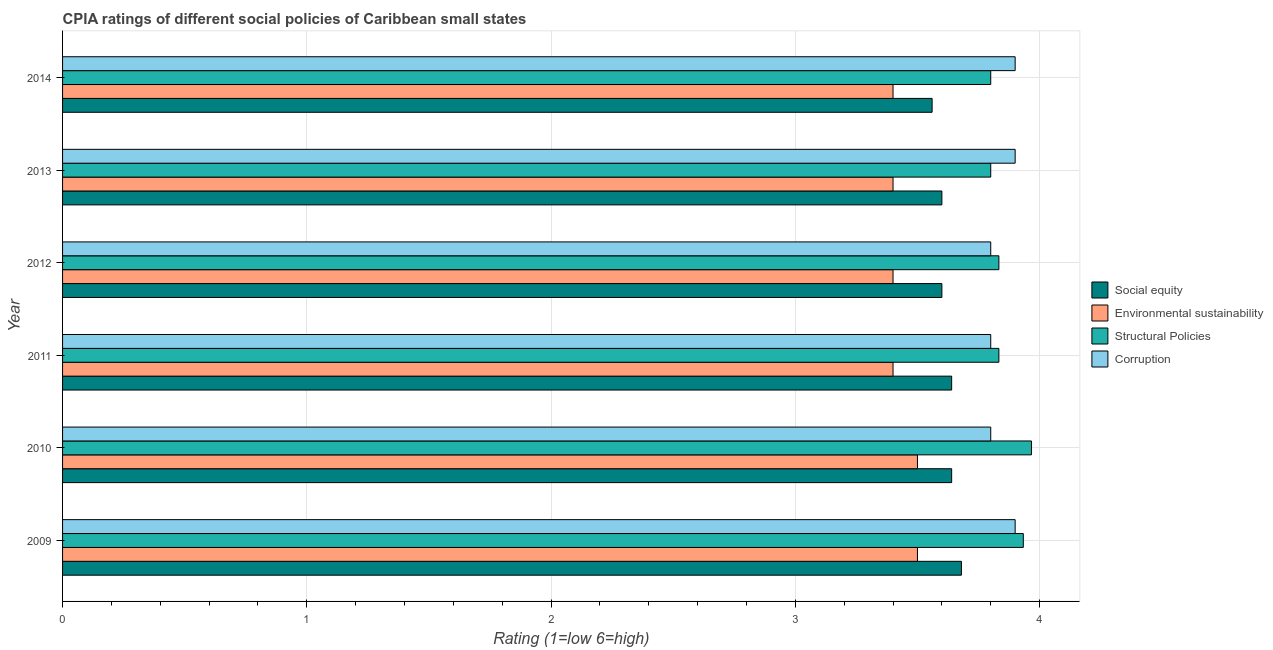How many groups of bars are there?
Ensure brevity in your answer.  6. Are the number of bars per tick equal to the number of legend labels?
Offer a terse response. Yes. Are the number of bars on each tick of the Y-axis equal?
Provide a short and direct response. Yes. How many bars are there on the 2nd tick from the bottom?
Provide a succinct answer. 4. What is the cpia rating of environmental sustainability in 2014?
Ensure brevity in your answer.  3.4. Across all years, what is the maximum cpia rating of corruption?
Provide a succinct answer. 3.9. Across all years, what is the minimum cpia rating of corruption?
Provide a short and direct response. 3.8. In which year was the cpia rating of social equity maximum?
Give a very brief answer. 2009. What is the total cpia rating of environmental sustainability in the graph?
Offer a very short reply. 20.6. What is the difference between the cpia rating of social equity in 2012 and that in 2013?
Your response must be concise. 0. What is the difference between the cpia rating of structural policies in 2013 and the cpia rating of environmental sustainability in 2011?
Ensure brevity in your answer.  0.4. What is the average cpia rating of environmental sustainability per year?
Your response must be concise. 3.43. In the year 2011, what is the difference between the cpia rating of corruption and cpia rating of structural policies?
Provide a succinct answer. -0.03. In how many years, is the cpia rating of social equity greater than 2.2 ?
Provide a short and direct response. 6. Is the cpia rating of environmental sustainability in 2009 less than that in 2012?
Offer a terse response. No. Is the difference between the cpia rating of corruption in 2013 and 2014 greater than the difference between the cpia rating of structural policies in 2013 and 2014?
Keep it short and to the point. No. What is the difference between the highest and the second highest cpia rating of social equity?
Your response must be concise. 0.04. What is the difference between the highest and the lowest cpia rating of structural policies?
Provide a succinct answer. 0.17. Is the sum of the cpia rating of social equity in 2009 and 2011 greater than the maximum cpia rating of corruption across all years?
Your answer should be compact. Yes. What does the 4th bar from the top in 2009 represents?
Give a very brief answer. Social equity. What does the 2nd bar from the bottom in 2012 represents?
Your answer should be very brief. Environmental sustainability. How many bars are there?
Provide a succinct answer. 24. How many years are there in the graph?
Offer a very short reply. 6. What is the difference between two consecutive major ticks on the X-axis?
Provide a succinct answer. 1. Are the values on the major ticks of X-axis written in scientific E-notation?
Ensure brevity in your answer.  No. Does the graph contain any zero values?
Offer a very short reply. No. How are the legend labels stacked?
Your response must be concise. Vertical. What is the title of the graph?
Offer a terse response. CPIA ratings of different social policies of Caribbean small states. Does "Taxes on goods and services" appear as one of the legend labels in the graph?
Offer a very short reply. No. What is the label or title of the X-axis?
Give a very brief answer. Rating (1=low 6=high). What is the Rating (1=low 6=high) of Social equity in 2009?
Give a very brief answer. 3.68. What is the Rating (1=low 6=high) of Structural Policies in 2009?
Provide a short and direct response. 3.93. What is the Rating (1=low 6=high) in Social equity in 2010?
Keep it short and to the point. 3.64. What is the Rating (1=low 6=high) in Structural Policies in 2010?
Give a very brief answer. 3.97. What is the Rating (1=low 6=high) of Social equity in 2011?
Make the answer very short. 3.64. What is the Rating (1=low 6=high) of Structural Policies in 2011?
Provide a short and direct response. 3.83. What is the Rating (1=low 6=high) in Structural Policies in 2012?
Provide a short and direct response. 3.83. What is the Rating (1=low 6=high) of Corruption in 2012?
Offer a terse response. 3.8. What is the Rating (1=low 6=high) in Social equity in 2013?
Offer a terse response. 3.6. What is the Rating (1=low 6=high) in Corruption in 2013?
Ensure brevity in your answer.  3.9. What is the Rating (1=low 6=high) of Social equity in 2014?
Offer a very short reply. 3.56. What is the Rating (1=low 6=high) in Structural Policies in 2014?
Provide a short and direct response. 3.8. What is the Rating (1=low 6=high) in Corruption in 2014?
Ensure brevity in your answer.  3.9. Across all years, what is the maximum Rating (1=low 6=high) of Social equity?
Your answer should be compact. 3.68. Across all years, what is the maximum Rating (1=low 6=high) in Environmental sustainability?
Ensure brevity in your answer.  3.5. Across all years, what is the maximum Rating (1=low 6=high) in Structural Policies?
Ensure brevity in your answer.  3.97. Across all years, what is the minimum Rating (1=low 6=high) of Social equity?
Make the answer very short. 3.56. Across all years, what is the minimum Rating (1=low 6=high) of Environmental sustainability?
Keep it short and to the point. 3.4. Across all years, what is the minimum Rating (1=low 6=high) in Structural Policies?
Offer a very short reply. 3.8. What is the total Rating (1=low 6=high) in Social equity in the graph?
Give a very brief answer. 21.72. What is the total Rating (1=low 6=high) in Environmental sustainability in the graph?
Keep it short and to the point. 20.6. What is the total Rating (1=low 6=high) in Structural Policies in the graph?
Offer a terse response. 23.17. What is the total Rating (1=low 6=high) of Corruption in the graph?
Ensure brevity in your answer.  23.1. What is the difference between the Rating (1=low 6=high) in Structural Policies in 2009 and that in 2010?
Provide a short and direct response. -0.03. What is the difference between the Rating (1=low 6=high) in Corruption in 2009 and that in 2010?
Your response must be concise. 0.1. What is the difference between the Rating (1=low 6=high) in Social equity in 2009 and that in 2011?
Keep it short and to the point. 0.04. What is the difference between the Rating (1=low 6=high) in Environmental sustainability in 2009 and that in 2011?
Your answer should be very brief. 0.1. What is the difference between the Rating (1=low 6=high) in Structural Policies in 2009 and that in 2011?
Provide a succinct answer. 0.1. What is the difference between the Rating (1=low 6=high) in Structural Policies in 2009 and that in 2012?
Give a very brief answer. 0.1. What is the difference between the Rating (1=low 6=high) of Environmental sustainability in 2009 and that in 2013?
Your answer should be compact. 0.1. What is the difference between the Rating (1=low 6=high) of Structural Policies in 2009 and that in 2013?
Offer a terse response. 0.13. What is the difference between the Rating (1=low 6=high) in Corruption in 2009 and that in 2013?
Offer a very short reply. 0. What is the difference between the Rating (1=low 6=high) in Social equity in 2009 and that in 2014?
Provide a short and direct response. 0.12. What is the difference between the Rating (1=low 6=high) of Environmental sustainability in 2009 and that in 2014?
Make the answer very short. 0.1. What is the difference between the Rating (1=low 6=high) in Structural Policies in 2009 and that in 2014?
Give a very brief answer. 0.13. What is the difference between the Rating (1=low 6=high) in Social equity in 2010 and that in 2011?
Provide a succinct answer. 0. What is the difference between the Rating (1=low 6=high) in Structural Policies in 2010 and that in 2011?
Keep it short and to the point. 0.13. What is the difference between the Rating (1=low 6=high) in Social equity in 2010 and that in 2012?
Offer a very short reply. 0.04. What is the difference between the Rating (1=low 6=high) of Structural Policies in 2010 and that in 2012?
Your response must be concise. 0.13. What is the difference between the Rating (1=low 6=high) in Social equity in 2010 and that in 2013?
Provide a short and direct response. 0.04. What is the difference between the Rating (1=low 6=high) in Corruption in 2010 and that in 2013?
Provide a succinct answer. -0.1. What is the difference between the Rating (1=low 6=high) of Environmental sustainability in 2010 and that in 2014?
Keep it short and to the point. 0.1. What is the difference between the Rating (1=low 6=high) in Structural Policies in 2010 and that in 2014?
Offer a terse response. 0.17. What is the difference between the Rating (1=low 6=high) of Structural Policies in 2011 and that in 2012?
Give a very brief answer. 0. What is the difference between the Rating (1=low 6=high) of Corruption in 2011 and that in 2012?
Your answer should be compact. 0. What is the difference between the Rating (1=low 6=high) of Social equity in 2011 and that in 2013?
Ensure brevity in your answer.  0.04. What is the difference between the Rating (1=low 6=high) of Environmental sustainability in 2011 and that in 2013?
Offer a terse response. 0. What is the difference between the Rating (1=low 6=high) in Structural Policies in 2011 and that in 2013?
Offer a very short reply. 0.03. What is the difference between the Rating (1=low 6=high) in Corruption in 2011 and that in 2013?
Give a very brief answer. -0.1. What is the difference between the Rating (1=low 6=high) of Structural Policies in 2011 and that in 2014?
Your response must be concise. 0.03. What is the difference between the Rating (1=low 6=high) of Corruption in 2011 and that in 2014?
Keep it short and to the point. -0.1. What is the difference between the Rating (1=low 6=high) of Social equity in 2012 and that in 2013?
Ensure brevity in your answer.  0. What is the difference between the Rating (1=low 6=high) in Structural Policies in 2012 and that in 2013?
Ensure brevity in your answer.  0.03. What is the difference between the Rating (1=low 6=high) of Corruption in 2012 and that in 2013?
Your answer should be compact. -0.1. What is the difference between the Rating (1=low 6=high) in Environmental sustainability in 2012 and that in 2014?
Provide a succinct answer. 0. What is the difference between the Rating (1=low 6=high) in Structural Policies in 2012 and that in 2014?
Your answer should be very brief. 0.03. What is the difference between the Rating (1=low 6=high) of Corruption in 2013 and that in 2014?
Provide a succinct answer. 0. What is the difference between the Rating (1=low 6=high) of Social equity in 2009 and the Rating (1=low 6=high) of Environmental sustainability in 2010?
Make the answer very short. 0.18. What is the difference between the Rating (1=low 6=high) of Social equity in 2009 and the Rating (1=low 6=high) of Structural Policies in 2010?
Ensure brevity in your answer.  -0.29. What is the difference between the Rating (1=low 6=high) of Social equity in 2009 and the Rating (1=low 6=high) of Corruption in 2010?
Provide a succinct answer. -0.12. What is the difference between the Rating (1=low 6=high) of Environmental sustainability in 2009 and the Rating (1=low 6=high) of Structural Policies in 2010?
Your answer should be very brief. -0.47. What is the difference between the Rating (1=low 6=high) in Environmental sustainability in 2009 and the Rating (1=low 6=high) in Corruption in 2010?
Provide a short and direct response. -0.3. What is the difference between the Rating (1=low 6=high) of Structural Policies in 2009 and the Rating (1=low 6=high) of Corruption in 2010?
Give a very brief answer. 0.13. What is the difference between the Rating (1=low 6=high) in Social equity in 2009 and the Rating (1=low 6=high) in Environmental sustainability in 2011?
Offer a very short reply. 0.28. What is the difference between the Rating (1=low 6=high) of Social equity in 2009 and the Rating (1=low 6=high) of Structural Policies in 2011?
Offer a terse response. -0.15. What is the difference between the Rating (1=low 6=high) of Social equity in 2009 and the Rating (1=low 6=high) of Corruption in 2011?
Keep it short and to the point. -0.12. What is the difference between the Rating (1=low 6=high) of Environmental sustainability in 2009 and the Rating (1=low 6=high) of Structural Policies in 2011?
Make the answer very short. -0.33. What is the difference between the Rating (1=low 6=high) of Environmental sustainability in 2009 and the Rating (1=low 6=high) of Corruption in 2011?
Your answer should be very brief. -0.3. What is the difference between the Rating (1=low 6=high) of Structural Policies in 2009 and the Rating (1=low 6=high) of Corruption in 2011?
Your response must be concise. 0.13. What is the difference between the Rating (1=low 6=high) in Social equity in 2009 and the Rating (1=low 6=high) in Environmental sustainability in 2012?
Give a very brief answer. 0.28. What is the difference between the Rating (1=low 6=high) in Social equity in 2009 and the Rating (1=low 6=high) in Structural Policies in 2012?
Your response must be concise. -0.15. What is the difference between the Rating (1=low 6=high) in Social equity in 2009 and the Rating (1=low 6=high) in Corruption in 2012?
Provide a succinct answer. -0.12. What is the difference between the Rating (1=low 6=high) of Structural Policies in 2009 and the Rating (1=low 6=high) of Corruption in 2012?
Give a very brief answer. 0.13. What is the difference between the Rating (1=low 6=high) in Social equity in 2009 and the Rating (1=low 6=high) in Environmental sustainability in 2013?
Ensure brevity in your answer.  0.28. What is the difference between the Rating (1=low 6=high) of Social equity in 2009 and the Rating (1=low 6=high) of Structural Policies in 2013?
Offer a very short reply. -0.12. What is the difference between the Rating (1=low 6=high) in Social equity in 2009 and the Rating (1=low 6=high) in Corruption in 2013?
Ensure brevity in your answer.  -0.22. What is the difference between the Rating (1=low 6=high) in Environmental sustainability in 2009 and the Rating (1=low 6=high) in Corruption in 2013?
Offer a terse response. -0.4. What is the difference between the Rating (1=low 6=high) in Structural Policies in 2009 and the Rating (1=low 6=high) in Corruption in 2013?
Ensure brevity in your answer.  0.03. What is the difference between the Rating (1=low 6=high) of Social equity in 2009 and the Rating (1=low 6=high) of Environmental sustainability in 2014?
Make the answer very short. 0.28. What is the difference between the Rating (1=low 6=high) in Social equity in 2009 and the Rating (1=low 6=high) in Structural Policies in 2014?
Provide a short and direct response. -0.12. What is the difference between the Rating (1=low 6=high) of Social equity in 2009 and the Rating (1=low 6=high) of Corruption in 2014?
Give a very brief answer. -0.22. What is the difference between the Rating (1=low 6=high) of Social equity in 2010 and the Rating (1=low 6=high) of Environmental sustainability in 2011?
Your answer should be very brief. 0.24. What is the difference between the Rating (1=low 6=high) of Social equity in 2010 and the Rating (1=low 6=high) of Structural Policies in 2011?
Your response must be concise. -0.19. What is the difference between the Rating (1=low 6=high) in Social equity in 2010 and the Rating (1=low 6=high) in Corruption in 2011?
Offer a very short reply. -0.16. What is the difference between the Rating (1=low 6=high) in Environmental sustainability in 2010 and the Rating (1=low 6=high) in Structural Policies in 2011?
Provide a succinct answer. -0.33. What is the difference between the Rating (1=low 6=high) of Social equity in 2010 and the Rating (1=low 6=high) of Environmental sustainability in 2012?
Offer a terse response. 0.24. What is the difference between the Rating (1=low 6=high) of Social equity in 2010 and the Rating (1=low 6=high) of Structural Policies in 2012?
Your answer should be compact. -0.19. What is the difference between the Rating (1=low 6=high) in Social equity in 2010 and the Rating (1=low 6=high) in Corruption in 2012?
Offer a very short reply. -0.16. What is the difference between the Rating (1=low 6=high) of Environmental sustainability in 2010 and the Rating (1=low 6=high) of Corruption in 2012?
Provide a short and direct response. -0.3. What is the difference between the Rating (1=low 6=high) in Structural Policies in 2010 and the Rating (1=low 6=high) in Corruption in 2012?
Offer a very short reply. 0.17. What is the difference between the Rating (1=low 6=high) in Social equity in 2010 and the Rating (1=low 6=high) in Environmental sustainability in 2013?
Your answer should be very brief. 0.24. What is the difference between the Rating (1=low 6=high) in Social equity in 2010 and the Rating (1=low 6=high) in Structural Policies in 2013?
Your response must be concise. -0.16. What is the difference between the Rating (1=low 6=high) of Social equity in 2010 and the Rating (1=low 6=high) of Corruption in 2013?
Your answer should be compact. -0.26. What is the difference between the Rating (1=low 6=high) of Environmental sustainability in 2010 and the Rating (1=low 6=high) of Corruption in 2013?
Keep it short and to the point. -0.4. What is the difference between the Rating (1=low 6=high) of Structural Policies in 2010 and the Rating (1=low 6=high) of Corruption in 2013?
Provide a succinct answer. 0.07. What is the difference between the Rating (1=low 6=high) in Social equity in 2010 and the Rating (1=low 6=high) in Environmental sustainability in 2014?
Ensure brevity in your answer.  0.24. What is the difference between the Rating (1=low 6=high) in Social equity in 2010 and the Rating (1=low 6=high) in Structural Policies in 2014?
Your answer should be compact. -0.16. What is the difference between the Rating (1=low 6=high) of Social equity in 2010 and the Rating (1=low 6=high) of Corruption in 2014?
Make the answer very short. -0.26. What is the difference between the Rating (1=low 6=high) of Environmental sustainability in 2010 and the Rating (1=low 6=high) of Structural Policies in 2014?
Offer a very short reply. -0.3. What is the difference between the Rating (1=low 6=high) of Environmental sustainability in 2010 and the Rating (1=low 6=high) of Corruption in 2014?
Your answer should be compact. -0.4. What is the difference between the Rating (1=low 6=high) of Structural Policies in 2010 and the Rating (1=low 6=high) of Corruption in 2014?
Offer a very short reply. 0.07. What is the difference between the Rating (1=low 6=high) of Social equity in 2011 and the Rating (1=low 6=high) of Environmental sustainability in 2012?
Keep it short and to the point. 0.24. What is the difference between the Rating (1=low 6=high) of Social equity in 2011 and the Rating (1=low 6=high) of Structural Policies in 2012?
Your answer should be compact. -0.19. What is the difference between the Rating (1=low 6=high) of Social equity in 2011 and the Rating (1=low 6=high) of Corruption in 2012?
Offer a terse response. -0.16. What is the difference between the Rating (1=low 6=high) in Environmental sustainability in 2011 and the Rating (1=low 6=high) in Structural Policies in 2012?
Offer a very short reply. -0.43. What is the difference between the Rating (1=low 6=high) in Environmental sustainability in 2011 and the Rating (1=low 6=high) in Corruption in 2012?
Provide a short and direct response. -0.4. What is the difference between the Rating (1=low 6=high) in Structural Policies in 2011 and the Rating (1=low 6=high) in Corruption in 2012?
Offer a very short reply. 0.03. What is the difference between the Rating (1=low 6=high) in Social equity in 2011 and the Rating (1=low 6=high) in Environmental sustainability in 2013?
Your response must be concise. 0.24. What is the difference between the Rating (1=low 6=high) in Social equity in 2011 and the Rating (1=low 6=high) in Structural Policies in 2013?
Give a very brief answer. -0.16. What is the difference between the Rating (1=low 6=high) in Social equity in 2011 and the Rating (1=low 6=high) in Corruption in 2013?
Your response must be concise. -0.26. What is the difference between the Rating (1=low 6=high) in Structural Policies in 2011 and the Rating (1=low 6=high) in Corruption in 2013?
Provide a short and direct response. -0.07. What is the difference between the Rating (1=low 6=high) of Social equity in 2011 and the Rating (1=low 6=high) of Environmental sustainability in 2014?
Provide a short and direct response. 0.24. What is the difference between the Rating (1=low 6=high) of Social equity in 2011 and the Rating (1=low 6=high) of Structural Policies in 2014?
Give a very brief answer. -0.16. What is the difference between the Rating (1=low 6=high) of Social equity in 2011 and the Rating (1=low 6=high) of Corruption in 2014?
Offer a very short reply. -0.26. What is the difference between the Rating (1=low 6=high) of Structural Policies in 2011 and the Rating (1=low 6=high) of Corruption in 2014?
Your answer should be very brief. -0.07. What is the difference between the Rating (1=low 6=high) in Social equity in 2012 and the Rating (1=low 6=high) in Environmental sustainability in 2013?
Give a very brief answer. 0.2. What is the difference between the Rating (1=low 6=high) in Social equity in 2012 and the Rating (1=low 6=high) in Corruption in 2013?
Make the answer very short. -0.3. What is the difference between the Rating (1=low 6=high) of Environmental sustainability in 2012 and the Rating (1=low 6=high) of Structural Policies in 2013?
Your response must be concise. -0.4. What is the difference between the Rating (1=low 6=high) in Environmental sustainability in 2012 and the Rating (1=low 6=high) in Corruption in 2013?
Provide a succinct answer. -0.5. What is the difference between the Rating (1=low 6=high) in Structural Policies in 2012 and the Rating (1=low 6=high) in Corruption in 2013?
Your answer should be very brief. -0.07. What is the difference between the Rating (1=low 6=high) of Social equity in 2012 and the Rating (1=low 6=high) of Environmental sustainability in 2014?
Your answer should be compact. 0.2. What is the difference between the Rating (1=low 6=high) of Social equity in 2012 and the Rating (1=low 6=high) of Corruption in 2014?
Your response must be concise. -0.3. What is the difference between the Rating (1=low 6=high) of Environmental sustainability in 2012 and the Rating (1=low 6=high) of Corruption in 2014?
Make the answer very short. -0.5. What is the difference between the Rating (1=low 6=high) in Structural Policies in 2012 and the Rating (1=low 6=high) in Corruption in 2014?
Your answer should be very brief. -0.07. What is the difference between the Rating (1=low 6=high) in Social equity in 2013 and the Rating (1=low 6=high) in Structural Policies in 2014?
Your answer should be very brief. -0.2. What is the difference between the Rating (1=low 6=high) of Social equity in 2013 and the Rating (1=low 6=high) of Corruption in 2014?
Make the answer very short. -0.3. What is the difference between the Rating (1=low 6=high) of Environmental sustainability in 2013 and the Rating (1=low 6=high) of Structural Policies in 2014?
Offer a very short reply. -0.4. What is the difference between the Rating (1=low 6=high) in Environmental sustainability in 2013 and the Rating (1=low 6=high) in Corruption in 2014?
Your answer should be compact. -0.5. What is the average Rating (1=low 6=high) of Social equity per year?
Keep it short and to the point. 3.62. What is the average Rating (1=low 6=high) in Environmental sustainability per year?
Keep it short and to the point. 3.43. What is the average Rating (1=low 6=high) in Structural Policies per year?
Give a very brief answer. 3.86. What is the average Rating (1=low 6=high) of Corruption per year?
Offer a terse response. 3.85. In the year 2009, what is the difference between the Rating (1=low 6=high) in Social equity and Rating (1=low 6=high) in Environmental sustainability?
Provide a succinct answer. 0.18. In the year 2009, what is the difference between the Rating (1=low 6=high) in Social equity and Rating (1=low 6=high) in Structural Policies?
Offer a very short reply. -0.25. In the year 2009, what is the difference between the Rating (1=low 6=high) in Social equity and Rating (1=low 6=high) in Corruption?
Ensure brevity in your answer.  -0.22. In the year 2009, what is the difference between the Rating (1=low 6=high) in Environmental sustainability and Rating (1=low 6=high) in Structural Policies?
Your response must be concise. -0.43. In the year 2009, what is the difference between the Rating (1=low 6=high) in Environmental sustainability and Rating (1=low 6=high) in Corruption?
Provide a short and direct response. -0.4. In the year 2010, what is the difference between the Rating (1=low 6=high) of Social equity and Rating (1=low 6=high) of Environmental sustainability?
Provide a succinct answer. 0.14. In the year 2010, what is the difference between the Rating (1=low 6=high) in Social equity and Rating (1=low 6=high) in Structural Policies?
Your response must be concise. -0.33. In the year 2010, what is the difference between the Rating (1=low 6=high) in Social equity and Rating (1=low 6=high) in Corruption?
Your response must be concise. -0.16. In the year 2010, what is the difference between the Rating (1=low 6=high) of Environmental sustainability and Rating (1=low 6=high) of Structural Policies?
Make the answer very short. -0.47. In the year 2010, what is the difference between the Rating (1=low 6=high) in Environmental sustainability and Rating (1=low 6=high) in Corruption?
Your answer should be compact. -0.3. In the year 2010, what is the difference between the Rating (1=low 6=high) in Structural Policies and Rating (1=low 6=high) in Corruption?
Provide a short and direct response. 0.17. In the year 2011, what is the difference between the Rating (1=low 6=high) in Social equity and Rating (1=low 6=high) in Environmental sustainability?
Provide a succinct answer. 0.24. In the year 2011, what is the difference between the Rating (1=low 6=high) of Social equity and Rating (1=low 6=high) of Structural Policies?
Provide a succinct answer. -0.19. In the year 2011, what is the difference between the Rating (1=low 6=high) of Social equity and Rating (1=low 6=high) of Corruption?
Offer a terse response. -0.16. In the year 2011, what is the difference between the Rating (1=low 6=high) in Environmental sustainability and Rating (1=low 6=high) in Structural Policies?
Your answer should be very brief. -0.43. In the year 2011, what is the difference between the Rating (1=low 6=high) of Environmental sustainability and Rating (1=low 6=high) of Corruption?
Ensure brevity in your answer.  -0.4. In the year 2012, what is the difference between the Rating (1=low 6=high) in Social equity and Rating (1=low 6=high) in Structural Policies?
Give a very brief answer. -0.23. In the year 2012, what is the difference between the Rating (1=low 6=high) in Environmental sustainability and Rating (1=low 6=high) in Structural Policies?
Provide a succinct answer. -0.43. In the year 2013, what is the difference between the Rating (1=low 6=high) in Social equity and Rating (1=low 6=high) in Environmental sustainability?
Your answer should be compact. 0.2. In the year 2013, what is the difference between the Rating (1=low 6=high) in Social equity and Rating (1=low 6=high) in Structural Policies?
Your answer should be very brief. -0.2. In the year 2013, what is the difference between the Rating (1=low 6=high) of Environmental sustainability and Rating (1=low 6=high) of Corruption?
Your answer should be very brief. -0.5. In the year 2013, what is the difference between the Rating (1=low 6=high) of Structural Policies and Rating (1=low 6=high) of Corruption?
Provide a short and direct response. -0.1. In the year 2014, what is the difference between the Rating (1=low 6=high) in Social equity and Rating (1=low 6=high) in Environmental sustainability?
Keep it short and to the point. 0.16. In the year 2014, what is the difference between the Rating (1=low 6=high) of Social equity and Rating (1=low 6=high) of Structural Policies?
Offer a very short reply. -0.24. In the year 2014, what is the difference between the Rating (1=low 6=high) of Social equity and Rating (1=low 6=high) of Corruption?
Your answer should be very brief. -0.34. In the year 2014, what is the difference between the Rating (1=low 6=high) in Environmental sustainability and Rating (1=low 6=high) in Structural Policies?
Ensure brevity in your answer.  -0.4. In the year 2014, what is the difference between the Rating (1=low 6=high) in Environmental sustainability and Rating (1=low 6=high) in Corruption?
Offer a terse response. -0.5. In the year 2014, what is the difference between the Rating (1=low 6=high) in Structural Policies and Rating (1=low 6=high) in Corruption?
Provide a short and direct response. -0.1. What is the ratio of the Rating (1=low 6=high) of Social equity in 2009 to that in 2010?
Your answer should be compact. 1.01. What is the ratio of the Rating (1=low 6=high) of Corruption in 2009 to that in 2010?
Your answer should be very brief. 1.03. What is the ratio of the Rating (1=low 6=high) in Environmental sustainability in 2009 to that in 2011?
Ensure brevity in your answer.  1.03. What is the ratio of the Rating (1=low 6=high) of Structural Policies in 2009 to that in 2011?
Offer a very short reply. 1.03. What is the ratio of the Rating (1=low 6=high) in Corruption in 2009 to that in 2011?
Your response must be concise. 1.03. What is the ratio of the Rating (1=low 6=high) of Social equity in 2009 to that in 2012?
Keep it short and to the point. 1.02. What is the ratio of the Rating (1=low 6=high) in Environmental sustainability in 2009 to that in 2012?
Ensure brevity in your answer.  1.03. What is the ratio of the Rating (1=low 6=high) of Structural Policies in 2009 to that in 2012?
Keep it short and to the point. 1.03. What is the ratio of the Rating (1=low 6=high) in Corruption in 2009 to that in 2012?
Give a very brief answer. 1.03. What is the ratio of the Rating (1=low 6=high) of Social equity in 2009 to that in 2013?
Make the answer very short. 1.02. What is the ratio of the Rating (1=low 6=high) of Environmental sustainability in 2009 to that in 2013?
Keep it short and to the point. 1.03. What is the ratio of the Rating (1=low 6=high) of Structural Policies in 2009 to that in 2013?
Your response must be concise. 1.04. What is the ratio of the Rating (1=low 6=high) in Social equity in 2009 to that in 2014?
Provide a succinct answer. 1.03. What is the ratio of the Rating (1=low 6=high) of Environmental sustainability in 2009 to that in 2014?
Your answer should be very brief. 1.03. What is the ratio of the Rating (1=low 6=high) in Structural Policies in 2009 to that in 2014?
Your answer should be very brief. 1.04. What is the ratio of the Rating (1=low 6=high) in Corruption in 2009 to that in 2014?
Keep it short and to the point. 1. What is the ratio of the Rating (1=low 6=high) in Social equity in 2010 to that in 2011?
Keep it short and to the point. 1. What is the ratio of the Rating (1=low 6=high) of Environmental sustainability in 2010 to that in 2011?
Offer a very short reply. 1.03. What is the ratio of the Rating (1=low 6=high) of Structural Policies in 2010 to that in 2011?
Provide a short and direct response. 1.03. What is the ratio of the Rating (1=low 6=high) of Social equity in 2010 to that in 2012?
Offer a terse response. 1.01. What is the ratio of the Rating (1=low 6=high) in Environmental sustainability in 2010 to that in 2012?
Provide a short and direct response. 1.03. What is the ratio of the Rating (1=low 6=high) of Structural Policies in 2010 to that in 2012?
Your answer should be compact. 1.03. What is the ratio of the Rating (1=low 6=high) of Social equity in 2010 to that in 2013?
Your answer should be compact. 1.01. What is the ratio of the Rating (1=low 6=high) in Environmental sustainability in 2010 to that in 2013?
Provide a succinct answer. 1.03. What is the ratio of the Rating (1=low 6=high) of Structural Policies in 2010 to that in 2013?
Offer a very short reply. 1.04. What is the ratio of the Rating (1=low 6=high) in Corruption in 2010 to that in 2013?
Provide a succinct answer. 0.97. What is the ratio of the Rating (1=low 6=high) in Social equity in 2010 to that in 2014?
Make the answer very short. 1.02. What is the ratio of the Rating (1=low 6=high) in Environmental sustainability in 2010 to that in 2014?
Make the answer very short. 1.03. What is the ratio of the Rating (1=low 6=high) of Structural Policies in 2010 to that in 2014?
Offer a terse response. 1.04. What is the ratio of the Rating (1=low 6=high) in Corruption in 2010 to that in 2014?
Provide a short and direct response. 0.97. What is the ratio of the Rating (1=low 6=high) of Social equity in 2011 to that in 2012?
Your answer should be very brief. 1.01. What is the ratio of the Rating (1=low 6=high) of Corruption in 2011 to that in 2012?
Your answer should be compact. 1. What is the ratio of the Rating (1=low 6=high) in Social equity in 2011 to that in 2013?
Your answer should be compact. 1.01. What is the ratio of the Rating (1=low 6=high) in Structural Policies in 2011 to that in 2013?
Your answer should be very brief. 1.01. What is the ratio of the Rating (1=low 6=high) in Corruption in 2011 to that in 2013?
Keep it short and to the point. 0.97. What is the ratio of the Rating (1=low 6=high) of Social equity in 2011 to that in 2014?
Ensure brevity in your answer.  1.02. What is the ratio of the Rating (1=low 6=high) of Structural Policies in 2011 to that in 2014?
Provide a succinct answer. 1.01. What is the ratio of the Rating (1=low 6=high) in Corruption in 2011 to that in 2014?
Ensure brevity in your answer.  0.97. What is the ratio of the Rating (1=low 6=high) of Social equity in 2012 to that in 2013?
Offer a terse response. 1. What is the ratio of the Rating (1=low 6=high) in Environmental sustainability in 2012 to that in 2013?
Your answer should be very brief. 1. What is the ratio of the Rating (1=low 6=high) of Structural Policies in 2012 to that in 2013?
Your response must be concise. 1.01. What is the ratio of the Rating (1=low 6=high) in Corruption in 2012 to that in 2013?
Your answer should be very brief. 0.97. What is the ratio of the Rating (1=low 6=high) in Social equity in 2012 to that in 2014?
Provide a short and direct response. 1.01. What is the ratio of the Rating (1=low 6=high) of Environmental sustainability in 2012 to that in 2014?
Provide a succinct answer. 1. What is the ratio of the Rating (1=low 6=high) of Structural Policies in 2012 to that in 2014?
Offer a terse response. 1.01. What is the ratio of the Rating (1=low 6=high) of Corruption in 2012 to that in 2014?
Your response must be concise. 0.97. What is the ratio of the Rating (1=low 6=high) of Social equity in 2013 to that in 2014?
Provide a succinct answer. 1.01. What is the ratio of the Rating (1=low 6=high) of Environmental sustainability in 2013 to that in 2014?
Provide a short and direct response. 1. What is the ratio of the Rating (1=low 6=high) in Structural Policies in 2013 to that in 2014?
Provide a succinct answer. 1. What is the ratio of the Rating (1=low 6=high) in Corruption in 2013 to that in 2014?
Your answer should be very brief. 1. What is the difference between the highest and the second highest Rating (1=low 6=high) of Social equity?
Give a very brief answer. 0.04. What is the difference between the highest and the second highest Rating (1=low 6=high) in Environmental sustainability?
Keep it short and to the point. 0. What is the difference between the highest and the second highest Rating (1=low 6=high) of Structural Policies?
Give a very brief answer. 0.03. What is the difference between the highest and the second highest Rating (1=low 6=high) of Corruption?
Give a very brief answer. 0. What is the difference between the highest and the lowest Rating (1=low 6=high) in Social equity?
Offer a very short reply. 0.12. What is the difference between the highest and the lowest Rating (1=low 6=high) in Structural Policies?
Your answer should be compact. 0.17. 